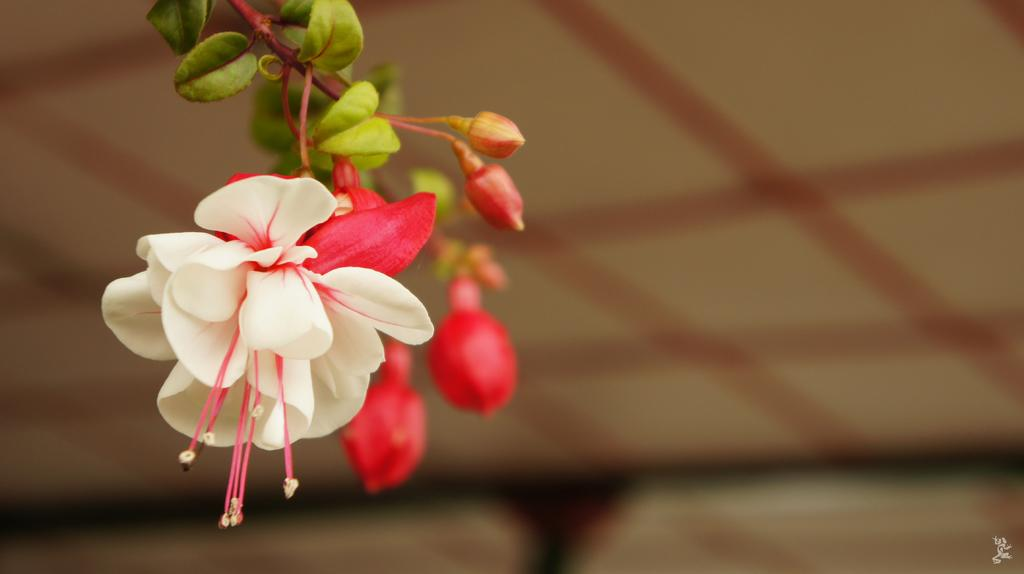What type of plant life can be seen in the image? There are flowers, buds, and leaves in the image. Can you describe the stage of growth for the plants in the image? The image shows both flowers and buds, indicating that some plants are in bloom while others are still developing. What is the appearance of the background in the image? The background of the image is blurred. What type of soda can be seen in the image? There is no soda present in the image; it features flowers, buds, and leaves. What does the voice of the plant sound like in the image? Plants do not have voices, so this question cannot be answered based on the image. 